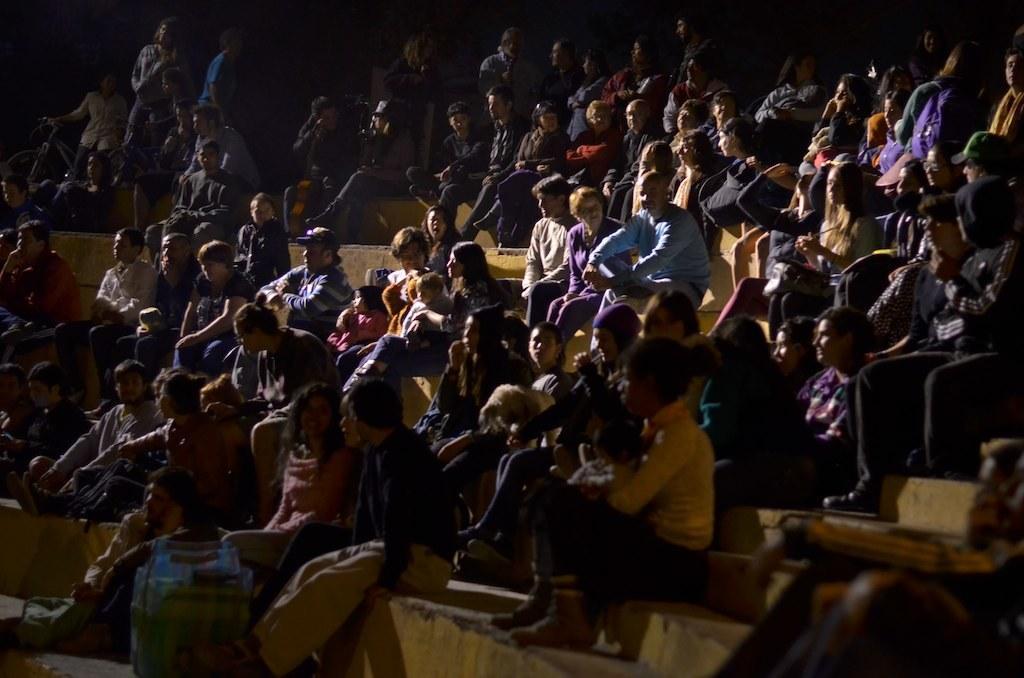How would you summarize this image in a sentence or two? This picture shows few people seated and few are standing and we see few are holding kids with their hands. 